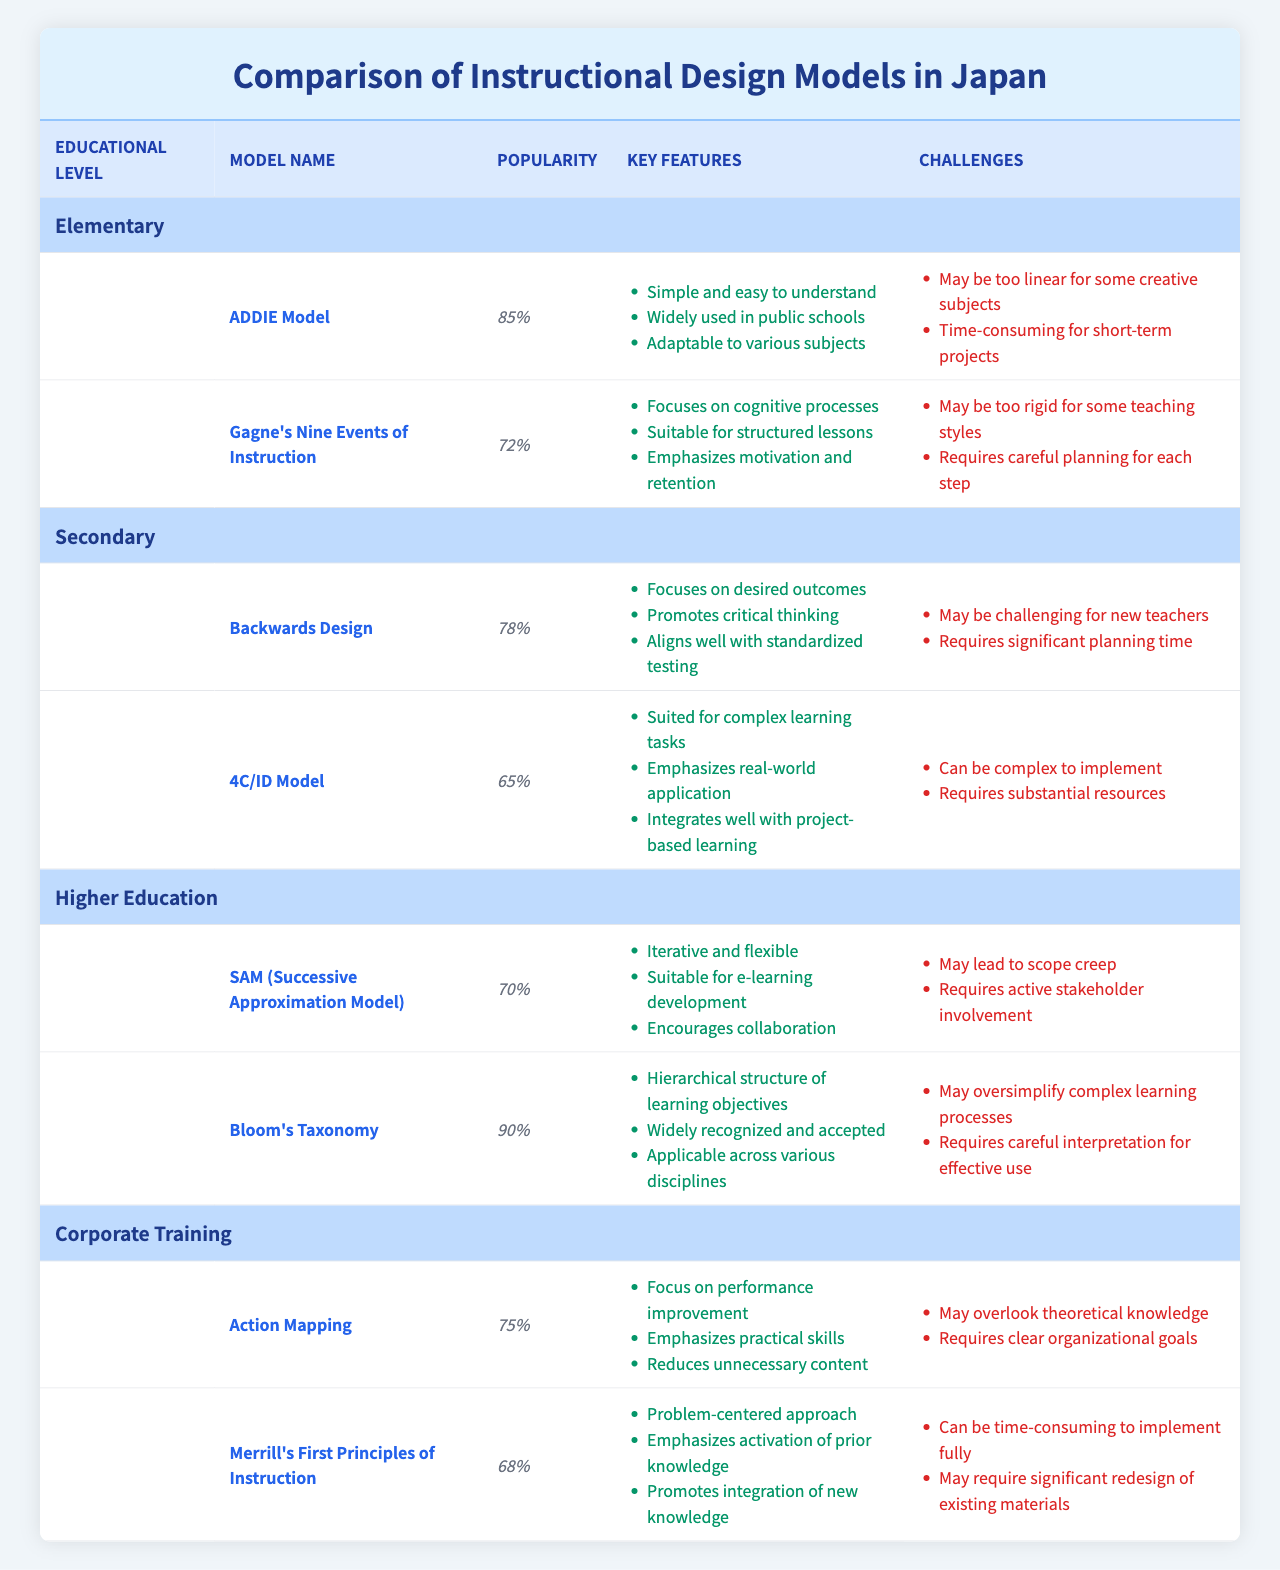What is the highest popularity score among the instructional design models listed? The table contains various instructional design models with their popularity scores. By reviewing the scores, Bloom's Taxonomy has a score of 90, which is higher than the others.
Answer: 90 Which instructional design model is the least popular in Secondary education? In the Secondary education category, the table shows two models: Backwards Design (78%) and 4C/ID Model (65%). The 4C/ID Model has the lowest popularity score of 65%.
Answer: 4C/ID Model How many key features does the ADDIE Model have? The ADDIE Model is listed under Elementary education and has three key features outlined in the table, including "Simple and easy to understand," "Widely used in public schools," and "Adaptable to various subjects."
Answer: 3 Is Gagne's Nine Events of Instruction more popular than the 4C/ID Model? Gagne's Nine Events of Instruction has a popularity score of 72%, while the 4C/ID Model has a popularity score of 65%. Since 72% is greater than 65%, Gagne's model is indeed more popular.
Answer: Yes What is the average popularity score of the instructional design models in Corporate Training? The table provides two models under Corporate Training: Action Mapping (75%) and Merrill's First Principles of Instruction (68%). The average is calculated as (75 + 68) / 2 = 71.5.
Answer: 71.5 Which model is the most popular for Higher Education, and what are its key features? The table indicates that Bloom's Taxonomy is the most popular in Higher Education with a score of 90%. Its key features include a hierarchical structure of learning objectives, wide recognition, and applicability across disciplines.
Answer: Bloom's Taxonomy Do any instructional design models in Elementary education have challenges related to time? The tables indicate that the ADDIE Model is time-consuming for short-term projects, indicating it faces a challenge related to time. Thus, there is at least one model that fits this description.
Answer: Yes What are the challenges of using the SAM Model for higher education? The SAM Model has two specific challenges noted in the table: it may lead to scope creep and requires active stakeholder involvement. Therefore, these challenges can hinder its implementation.
Answer: Scope creep and stakeholder involvement Which educational level has the highest variety of instructional design models listed? By examining the table closely, we see that Elementary education has two models listed, as do Secondary and Corporate Training. Higher Education also features two models. Therefore, none has a higher variety than the others; they all have the same number.
Answer: None, they are all equal Which key feature distinguishes Backwards Design from other models? Backwards Design emphasizes focusing on desired outcomes. This goal-oriented feature stands out compared to other models that might focus on processes or content.
Answer: Focus on desired outcomes What is the difference in popularity between ADDIE Model and Action Mapping? The popularity of the ADDIE Model is 85%, while Action Mapping has a score of 75%. The difference between these scores is 85% - 75% = 10%.
Answer: 10% 